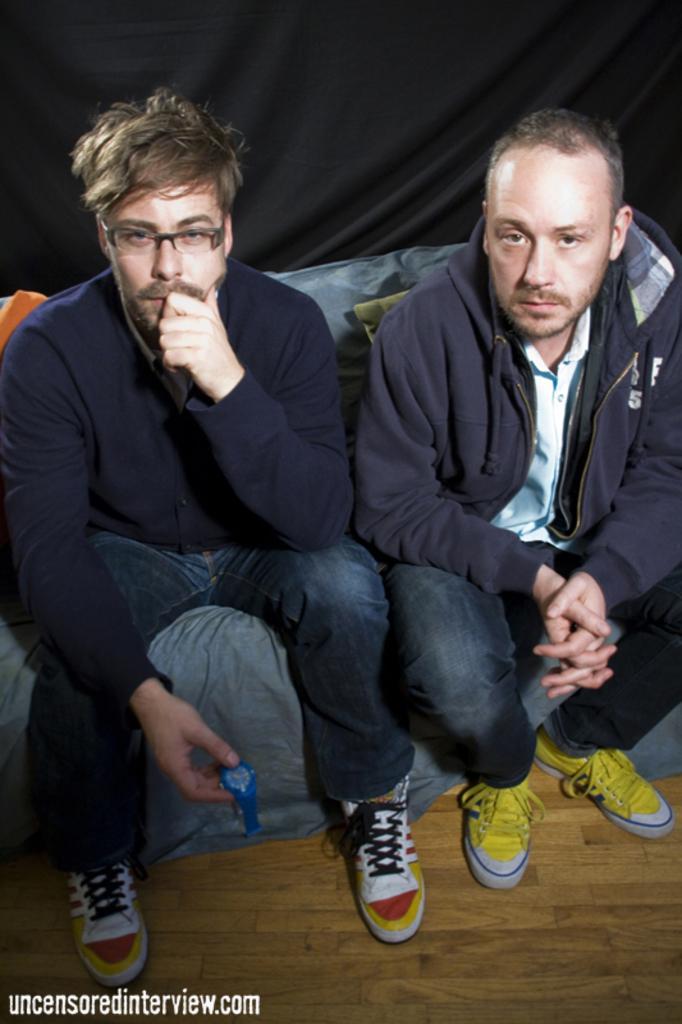Describe this image in one or two sentences. In the foreground of this image, there are two men sitting on a couch wearing jackets. On the bottom, there is the wooden floor. In the background, there is a black curtain. 